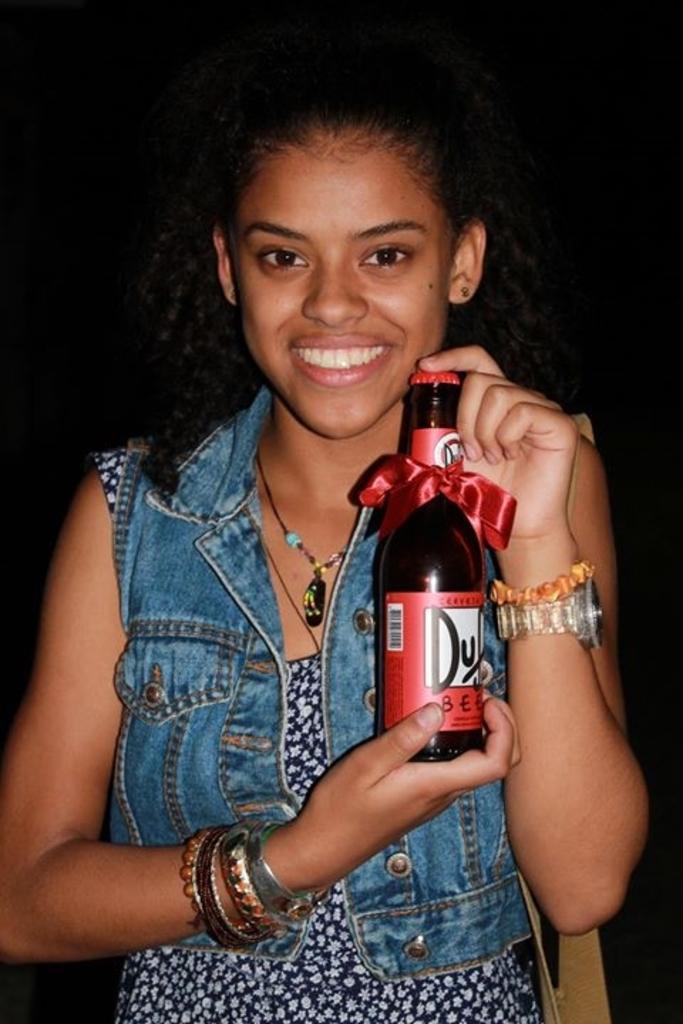How would you summarize this image in a sentence or two? In this picture there is a woman holding a bottle, she is wearing a jeans jacket. The background is dark. 